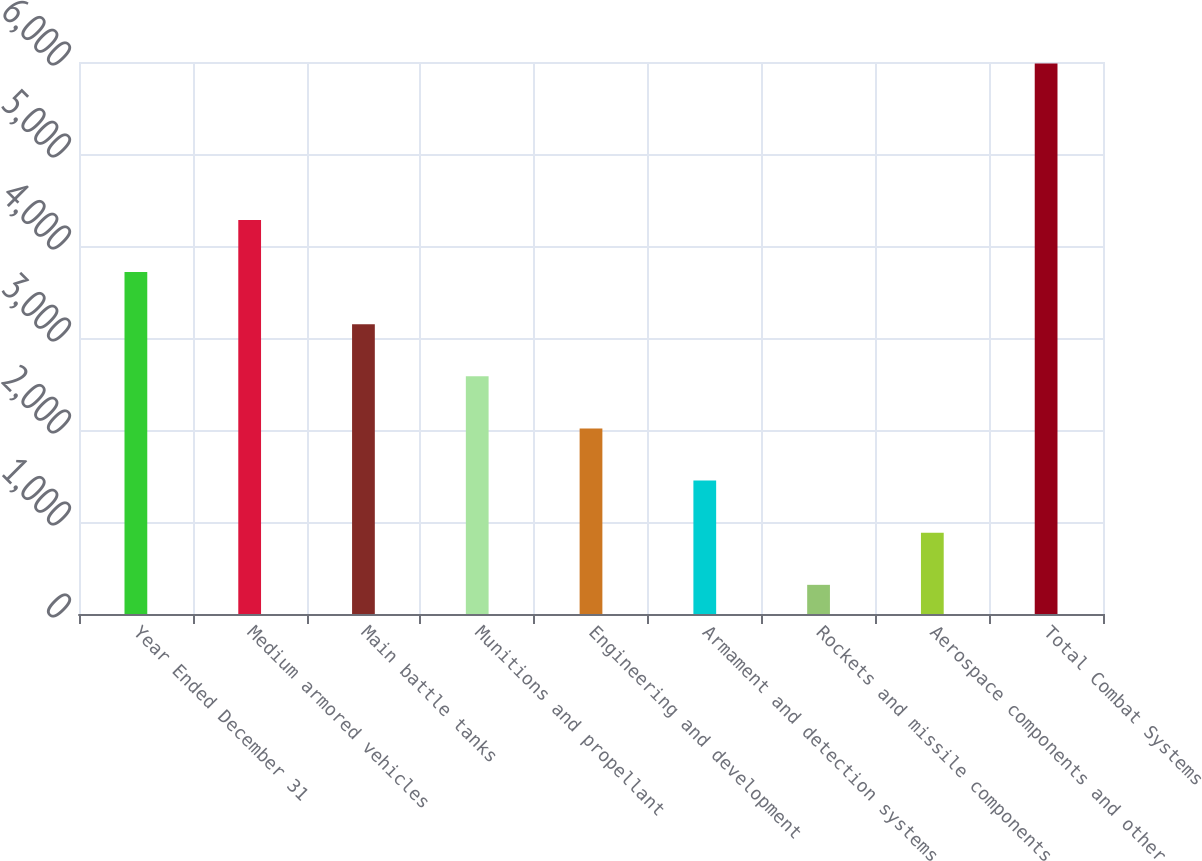Convert chart. <chart><loc_0><loc_0><loc_500><loc_500><bar_chart><fcel>Year Ended December 31<fcel>Medium armored vehicles<fcel>Main battle tanks<fcel>Munitions and propellant<fcel>Engineering and development<fcel>Armament and detection systems<fcel>Rockets and missile components<fcel>Aerospace components and other<fcel>Total Combat Systems<nl><fcel>3716.6<fcel>4283.2<fcel>3150<fcel>2583.4<fcel>2016.8<fcel>1450.2<fcel>317<fcel>883.6<fcel>5983<nl></chart> 